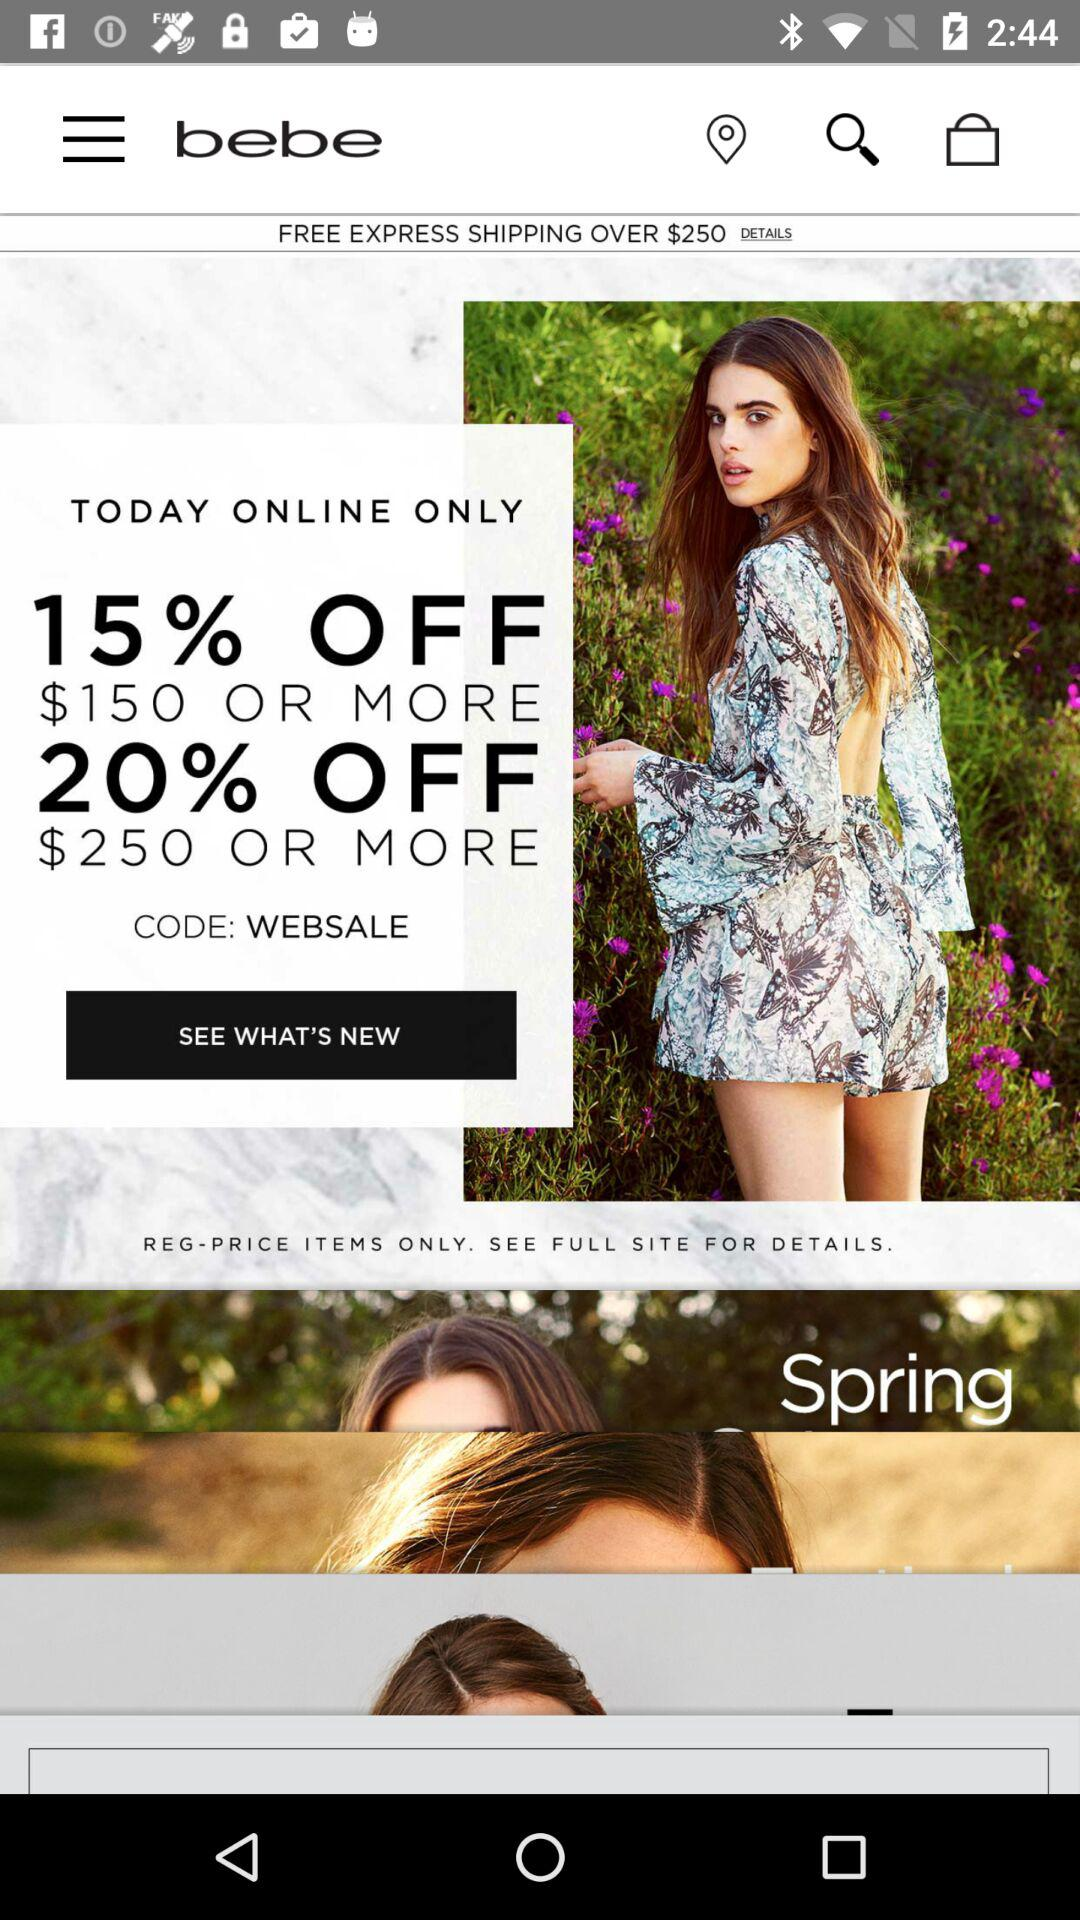How many different discounts are available?
Answer the question using a single word or phrase. 2 